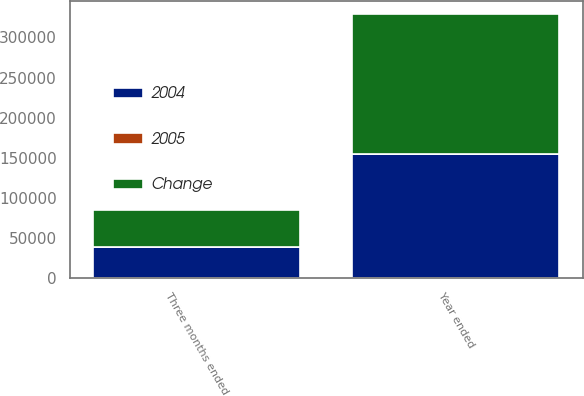<chart> <loc_0><loc_0><loc_500><loc_500><stacked_bar_chart><ecel><fcel>Three months ended<fcel>Year ended<nl><fcel>2004<fcel>38194<fcel>154211<nl><fcel>Change<fcel>46121<fcel>175073<nl><fcel>2005<fcel>17.2<fcel>11.9<nl></chart> 